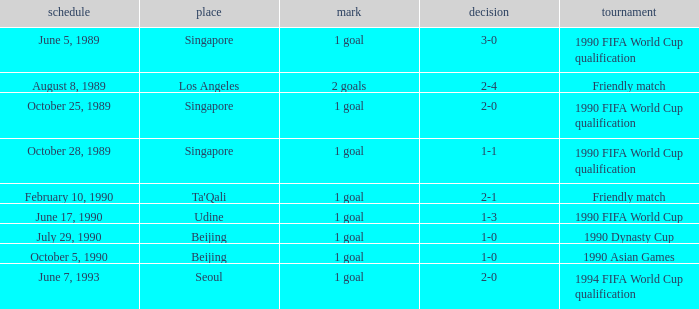What is the competition at the ta'qali venue? Friendly match. 